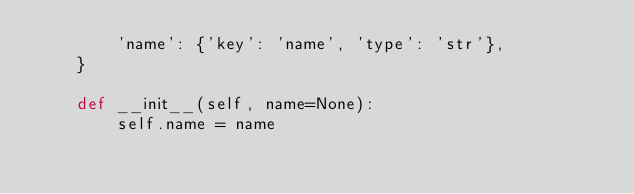<code> <loc_0><loc_0><loc_500><loc_500><_Python_>        'name': {'key': 'name', 'type': 'str'},
    }

    def __init__(self, name=None):
        self.name = name
</code> 